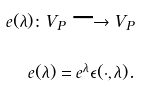Convert formula to latex. <formula><loc_0><loc_0><loc_500><loc_500>e ( \lambda ) \colon V _ { P } \longrightarrow V _ { P } \\ e ( \lambda ) = e ^ { \lambda } \epsilon ( \cdot , \lambda ) .</formula> 